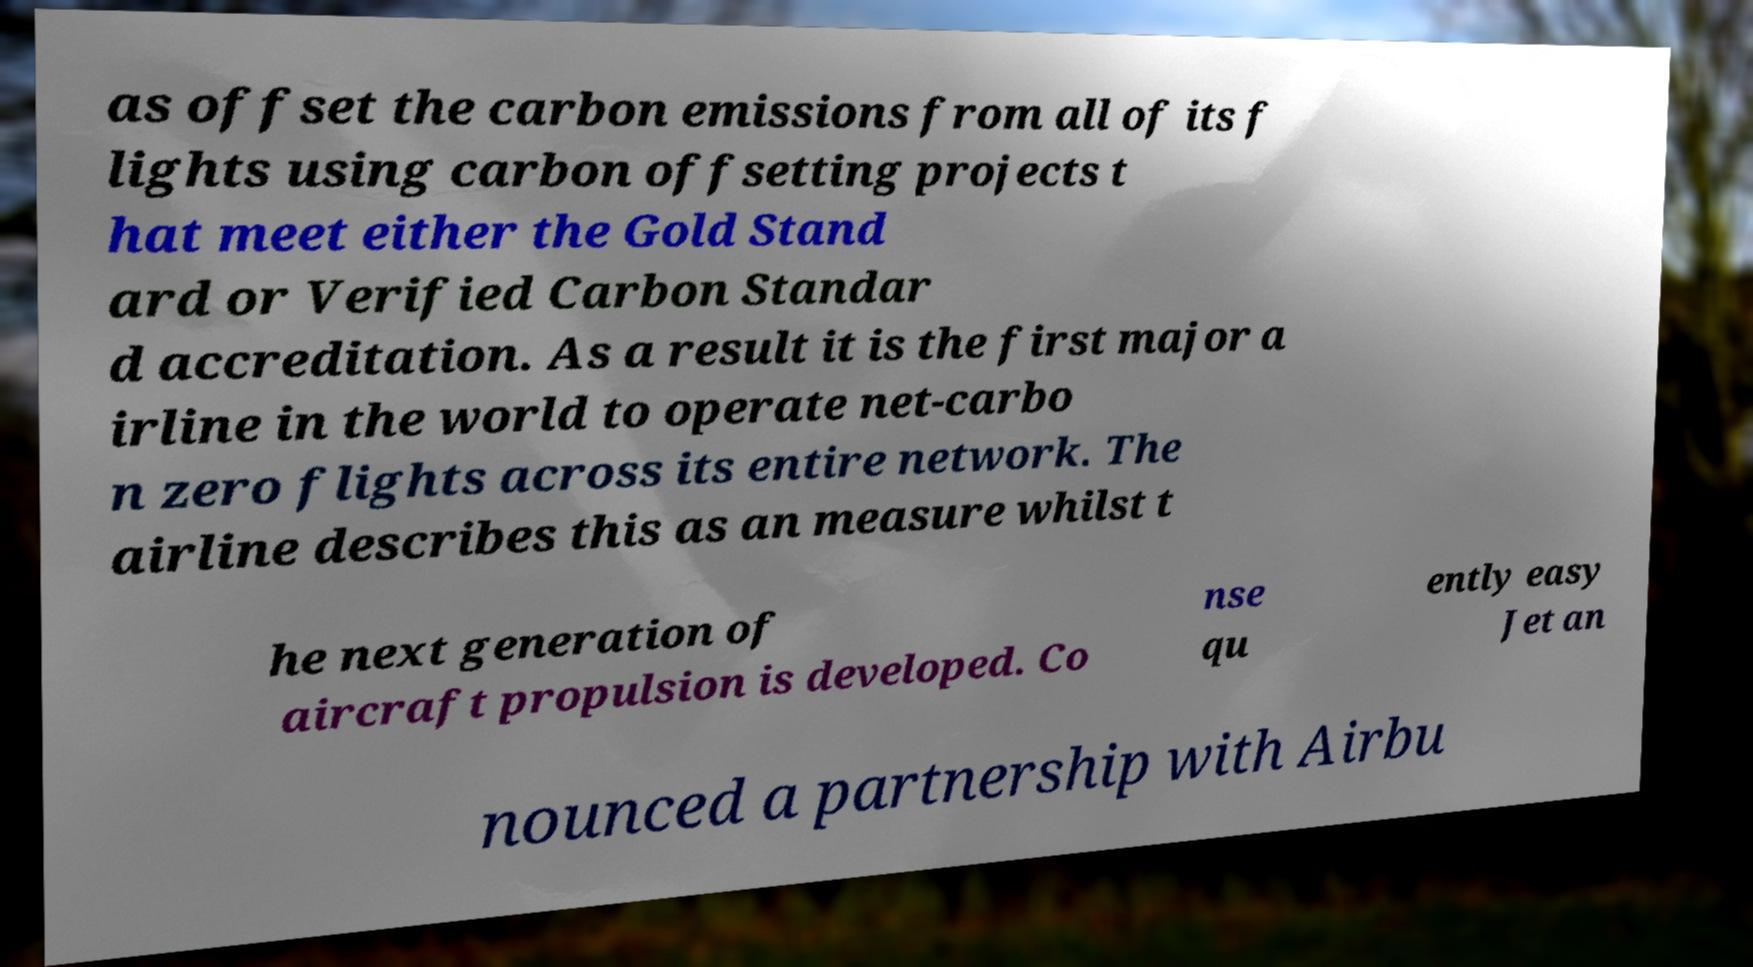For documentation purposes, I need the text within this image transcribed. Could you provide that? as offset the carbon emissions from all of its f lights using carbon offsetting projects t hat meet either the Gold Stand ard or Verified Carbon Standar d accreditation. As a result it is the first major a irline in the world to operate net-carbo n zero flights across its entire network. The airline describes this as an measure whilst t he next generation of aircraft propulsion is developed. Co nse qu ently easy Jet an nounced a partnership with Airbu 